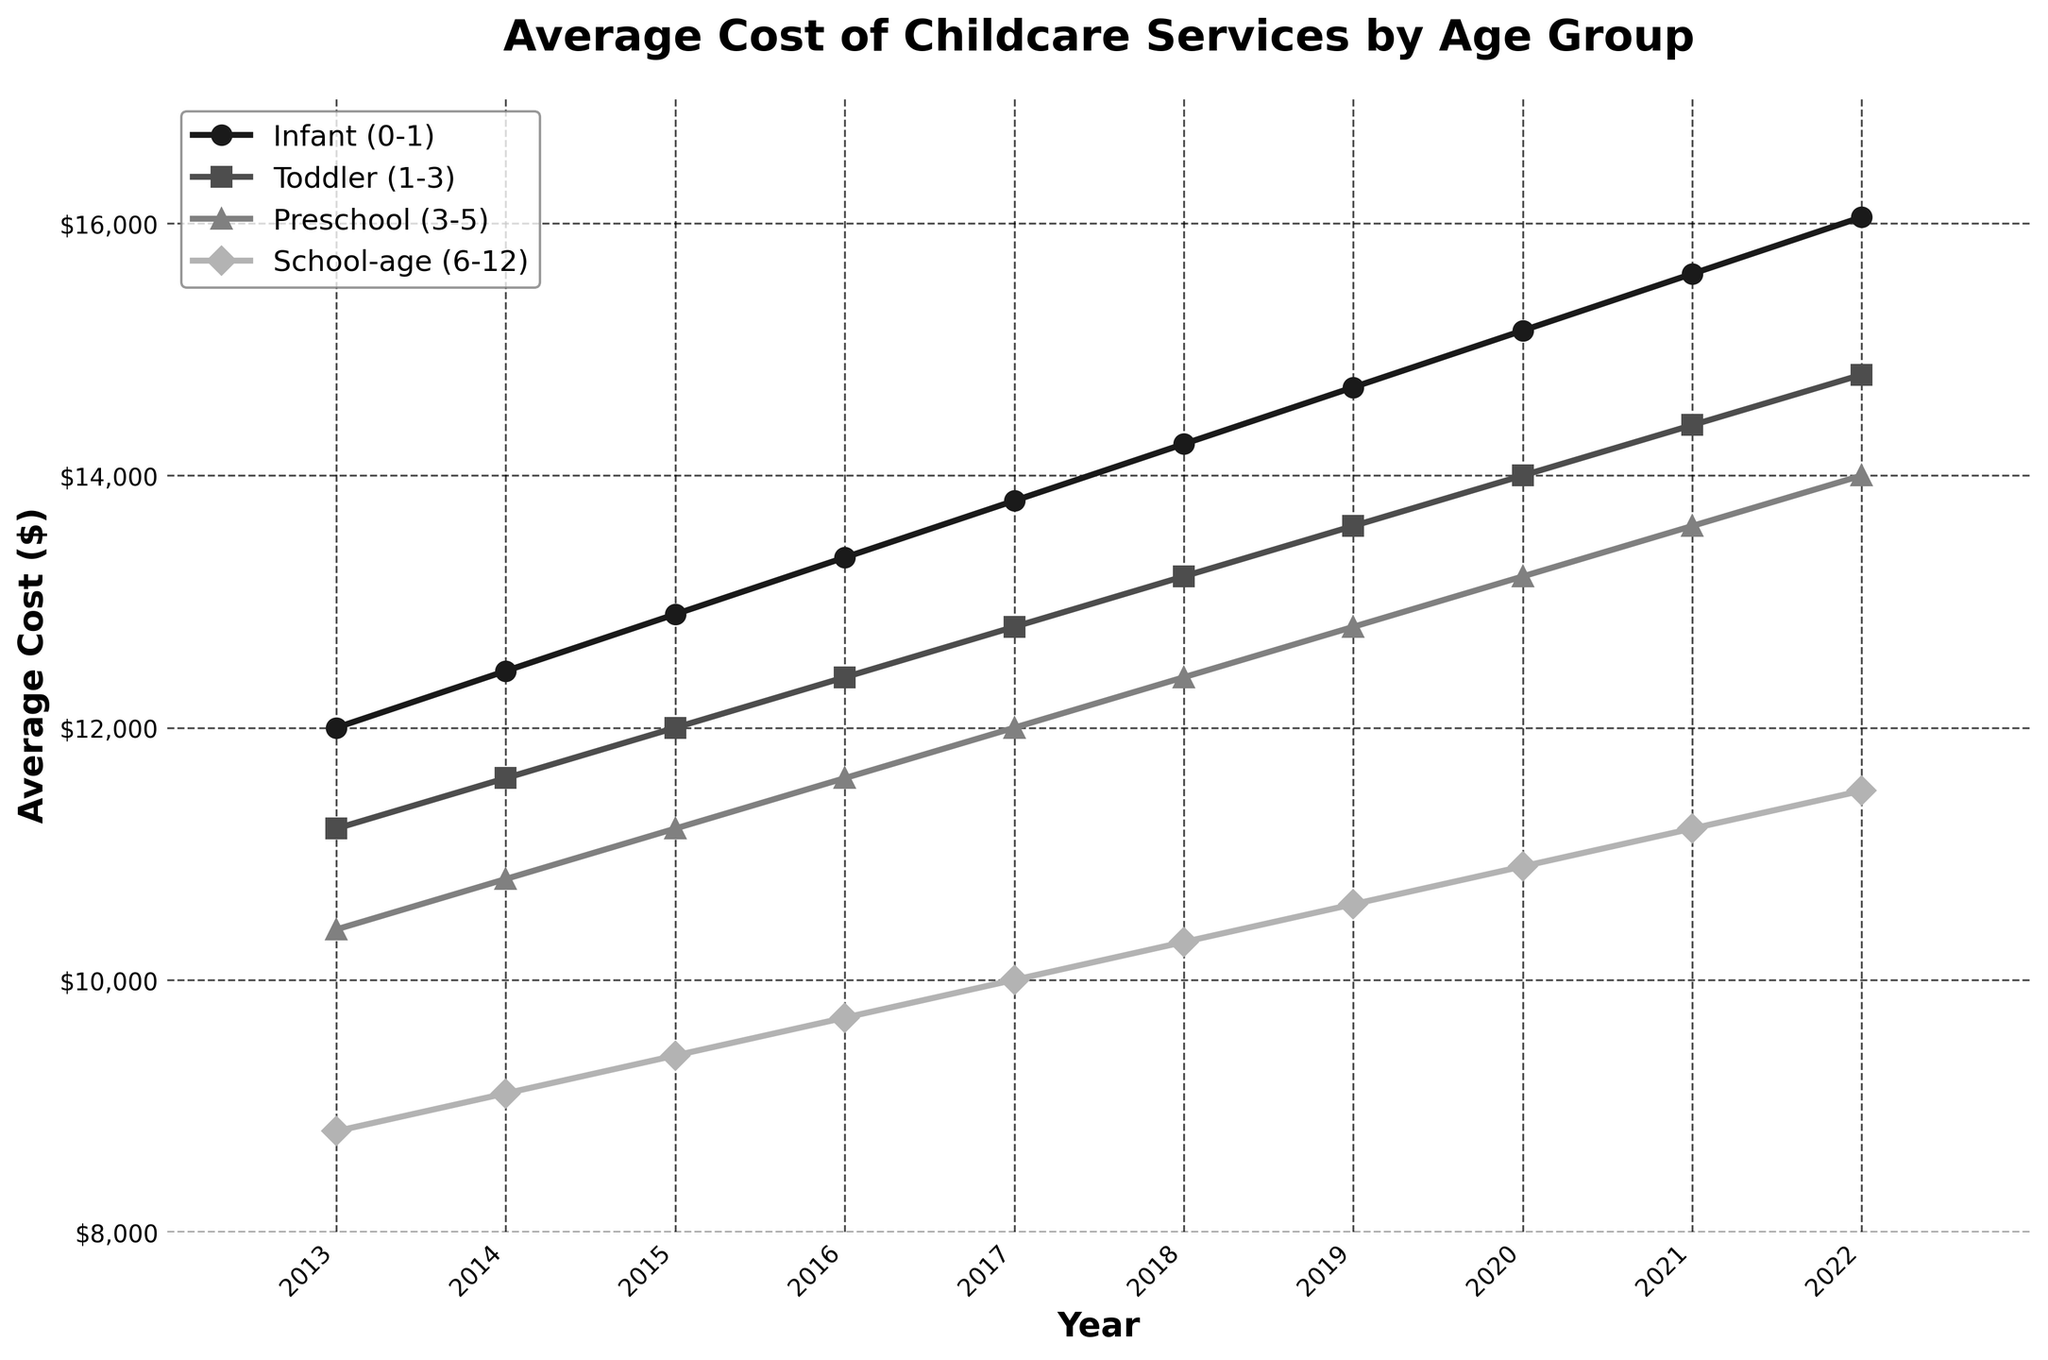How has the cost for infant (0-1) care changed from 2013 to 2022? The plot shows that in 2013, the cost for infant care was $12,000 and in 2022, it increased to $16,050. Calculating the difference: $16,050 - $12,000 gives the increase.
Answer: $4,050 Which age group had the highest average cost in 2020? By reviewing the 2020 data points on the graph, the cost for infants is highest at $15,150 compared to toddlers at $14,000, preschool-age at $13,200, and school-age at $10,900.
Answer: Infant (0-1) What is the trend in childcare costs for school-age children (6-12) over the decade? The plot shows an increasing trend for school-age childcare costs from $8,800 in 2013 to $11,500 in 2022. Each year, the cost consistently rises.
Answer: Increasing trend By how much did the cost of toddler care (1-3) increase between 2015 and 2019? From the plot, in 2015 the cost was $12,000, and in 2019 it was $13,600. Taking the difference, $13,600 - $12,000, provides the increase.
Answer: $1,600 Which age group saw the smallest overall increase in costs over the decade? The cost increases from 2013 to 2022 for each group are calculated: Infants increased by $4,050, Toddlers by $3,600, Preschool by $3,600, and School-age by $2,700. The smallest increase is for School-age children.
Answer: School-age (6-12) What can you infer about the rate of increase in costs for preschool-age children (3-5) compared to infant care over the decade? Both groups show an increasing cost trend. For preschoolers, the cost rose from $10,400 in 2013 to $14,000 in 2022 (an increase of $3,600). For infants, it rose from $12,000 to $16,050 (an increase of $4,050). The rate of increase is higher for infants.
Answer: Higher for infants Did any age group experience a cost decrease in any year? From the plot, we see that costs increase every year for all age groups without any decrease.
Answer: No What is the average cost of childcare for toddlers (1-3) over the entire decade? Sum the yearly costs for toddlers from 2013 to 2022, then divide by the number of years: (11200 + 11600 + 12000 + 12400 + 12800 + 13200 + 13600 + 14000 + 14400 + 14800) = 130000. Divide by 10 years.
Answer: $13,000 Which age group had the most consistent year-over-year increase? By examining the plot, each age group shows a consistent upward trend, but the plot lines for infants and toddlers appear most linear and steadily increasing without noticeable jumps. Infants' line is slightly more consistent.
Answer: Infant (0-1) How much more did it cost to care for an infant compared to a school-age child in 2022? From the plot, the 2022 costs are $16,050 for infants and $11,500 for school-age children. The difference is $16,050 - $11,500.
Answer: $4,550 